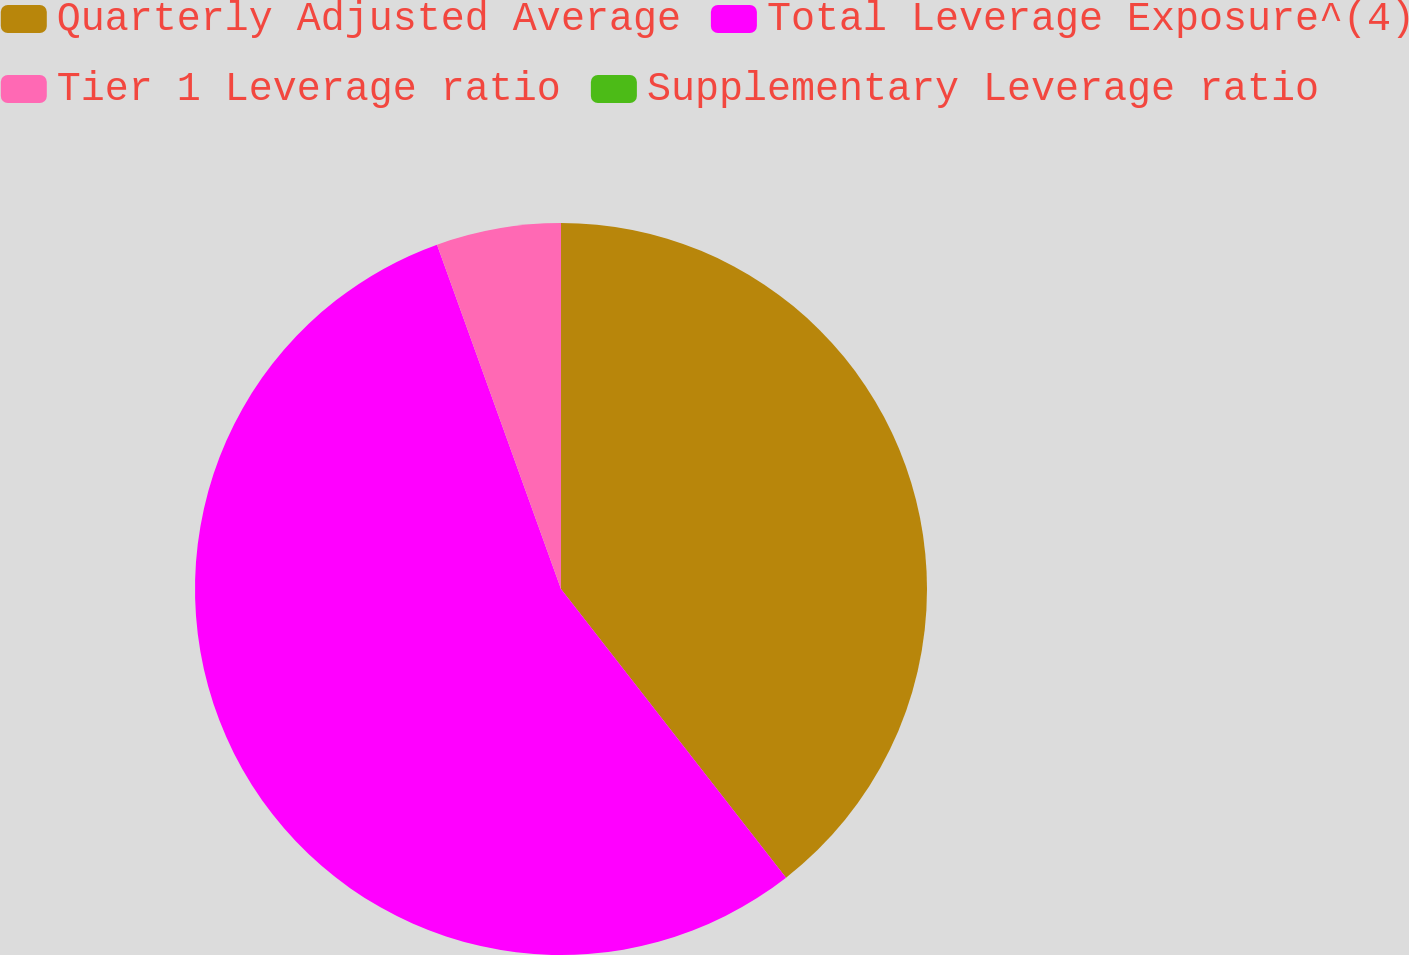<chart> <loc_0><loc_0><loc_500><loc_500><pie_chart><fcel>Quarterly Adjusted Average<fcel>Total Leverage Exposure^(4)<fcel>Tier 1 Leverage ratio<fcel>Supplementary Leverage ratio<nl><fcel>39.46%<fcel>55.04%<fcel>5.5%<fcel>0.0%<nl></chart> 